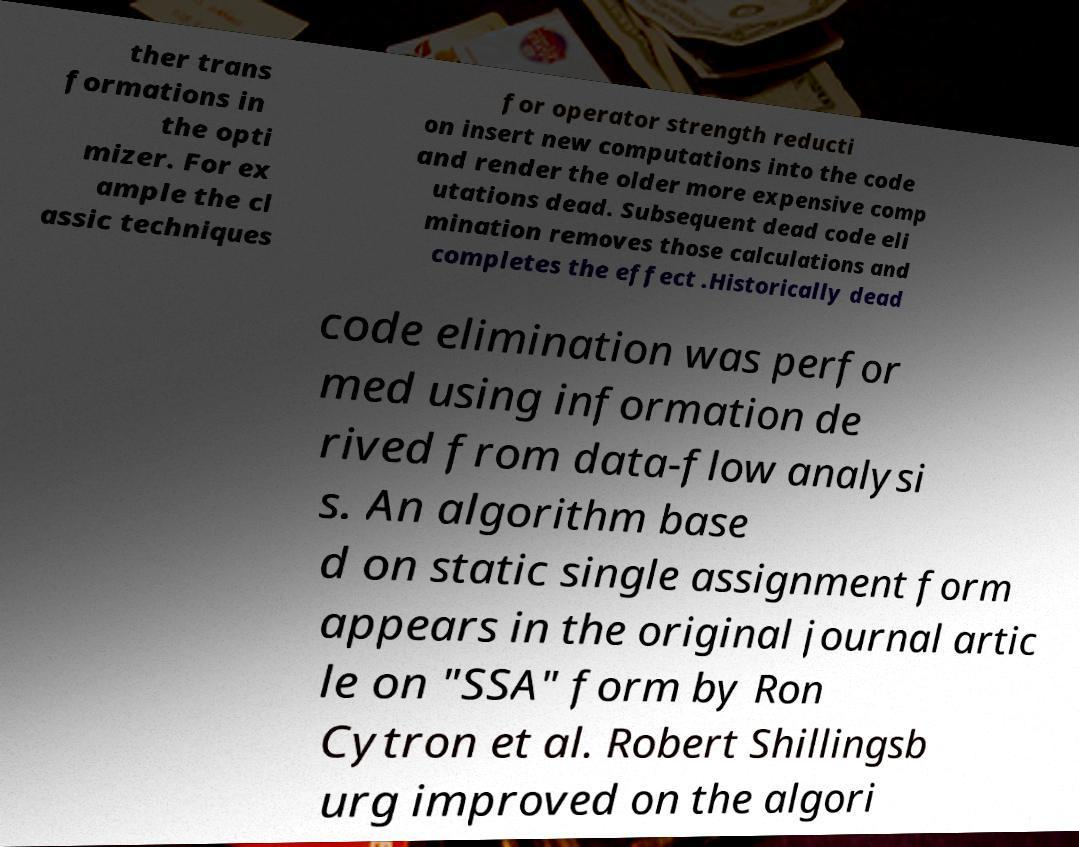There's text embedded in this image that I need extracted. Can you transcribe it verbatim? ther trans formations in the opti mizer. For ex ample the cl assic techniques for operator strength reducti on insert new computations into the code and render the older more expensive comp utations dead. Subsequent dead code eli mination removes those calculations and completes the effect .Historically dead code elimination was perfor med using information de rived from data-flow analysi s. An algorithm base d on static single assignment form appears in the original journal artic le on "SSA" form by Ron Cytron et al. Robert Shillingsb urg improved on the algori 